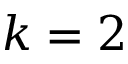Convert formula to latex. <formula><loc_0><loc_0><loc_500><loc_500>k = 2</formula> 